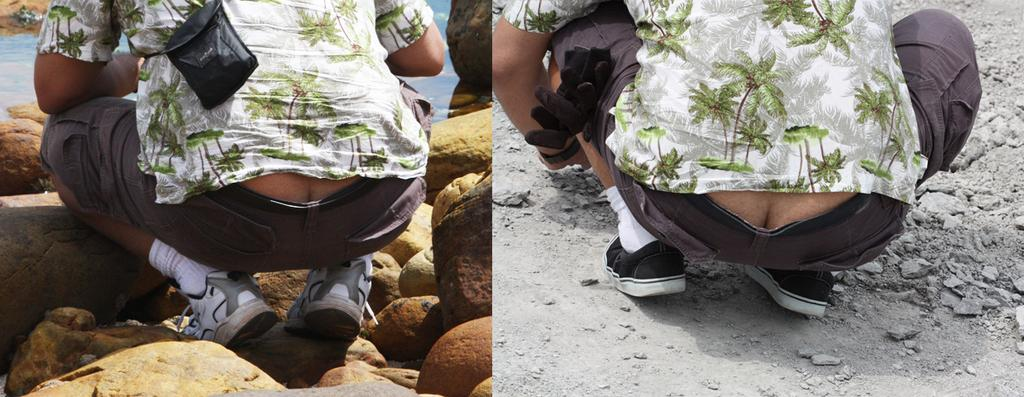How many people are present in the image? There are two people in the image. What type of objects can be seen in the image? There are stones and a bag visible in the image. Can you describe the unspecified objects in the image? Unfortunately, the facts provided do not specify the nature of the unspecified objects in the image. What type of desk is visible in the image? There is no desk present in the image. What is the condition of the earth in the image? The facts provided do not mention anything about the earth or its condition in the image. 